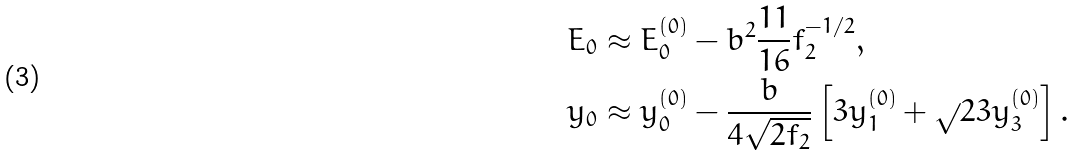Convert formula to latex. <formula><loc_0><loc_0><loc_500><loc_500>E _ { 0 } & \approx E _ { 0 } ^ { ( 0 ) } - b ^ { 2 } \frac { 1 1 } { 1 6 } f _ { 2 } ^ { - 1 / 2 } , \\ y _ { 0 } & \approx y _ { 0 } ^ { ( 0 ) } - \frac { b } { 4 \sqrt { 2 f _ { 2 } } } \left [ 3 y _ { 1 } ^ { ( 0 ) } + \sqrt { } { 2 } 3 y _ { 3 } ^ { ( 0 ) } \right ] .</formula> 